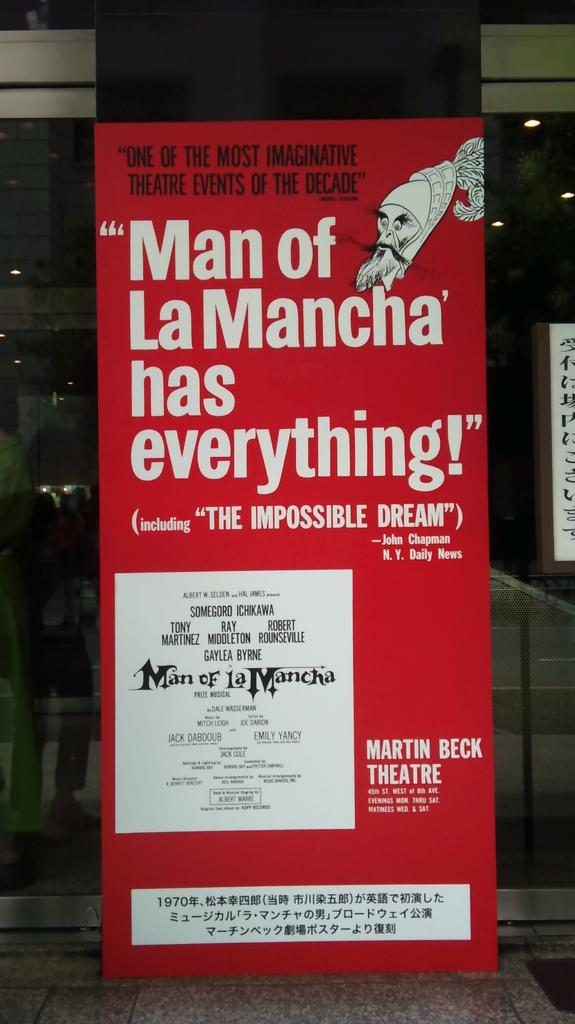<image>
Share a concise interpretation of the image provided. A theater poster for the Martin Beck Theater and their production of "Man of LaMancha" 